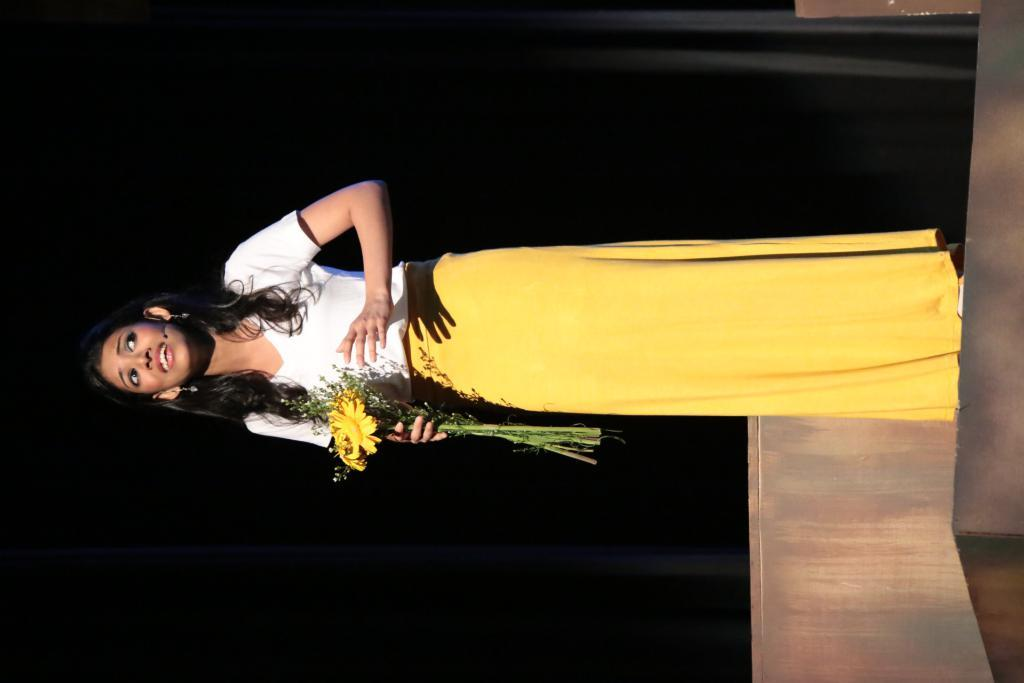Who is the main subject in the image? There is a girl in the image. What is the girl holding in the image? The girl is holding flowers. What is the color of the background in the image? The background of the image is black in color. What type of dog can be seen in the image? There is no dog present in the image. What advice might the minister give to the girl in the image? There is no minister present in the image, so it is not possible to determine what advice they might give. 